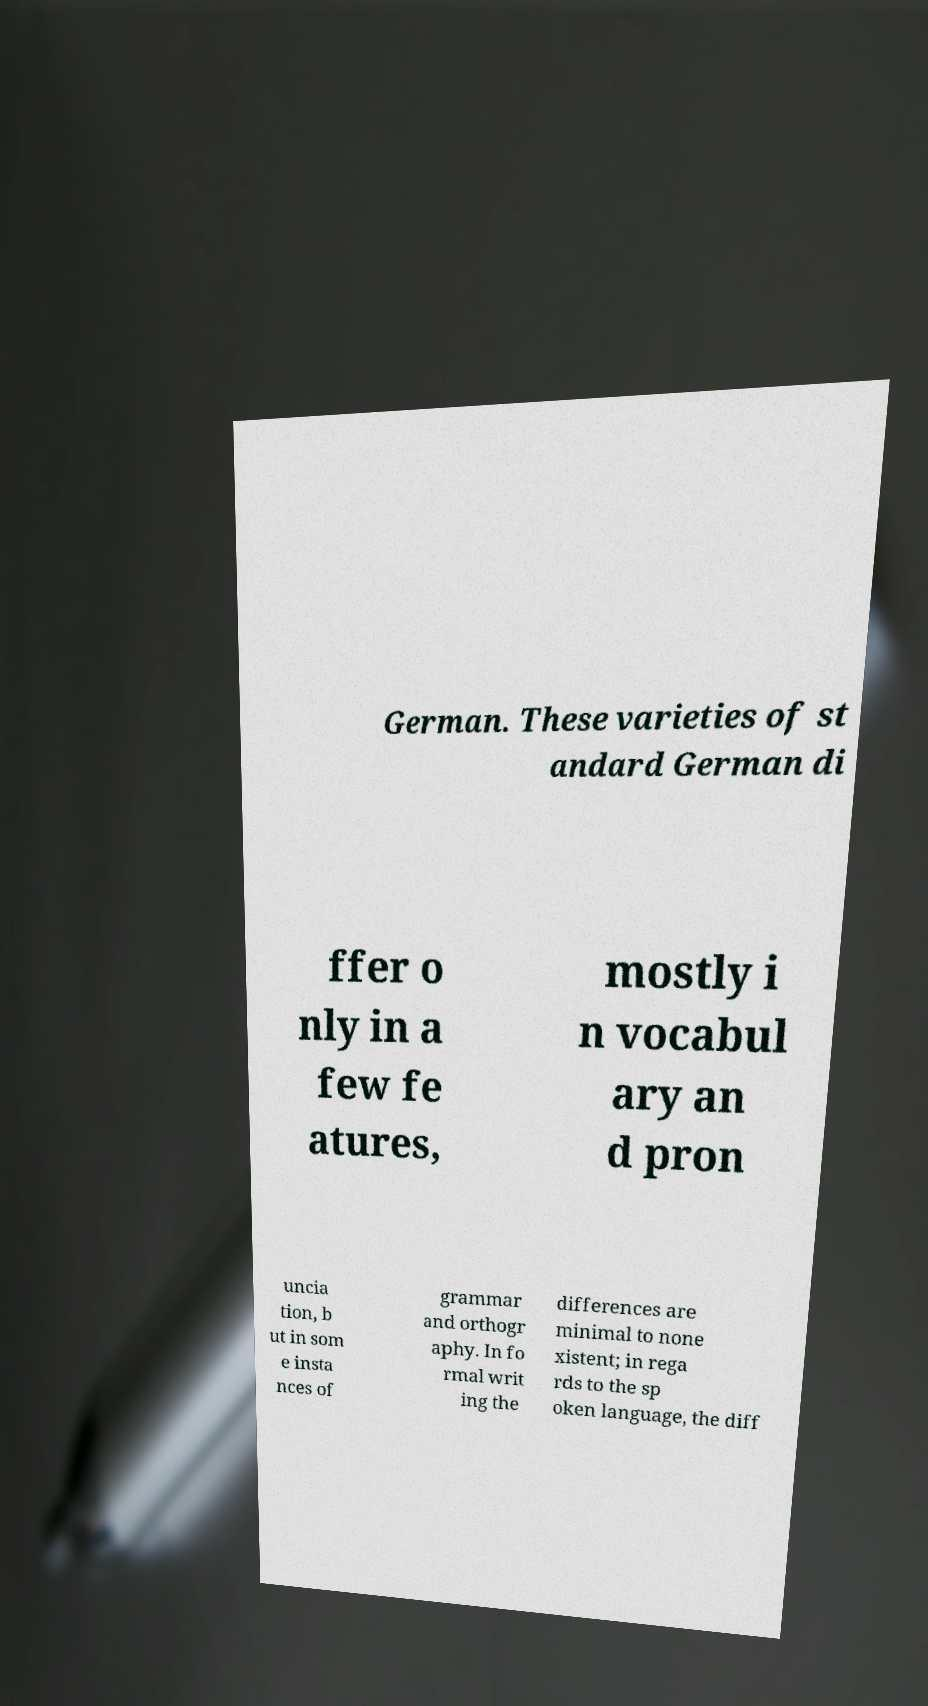Please identify and transcribe the text found in this image. German. These varieties of st andard German di ffer o nly in a few fe atures, mostly i n vocabul ary an d pron uncia tion, b ut in som e insta nces of grammar and orthogr aphy. In fo rmal writ ing the differences are minimal to none xistent; in rega rds to the sp oken language, the diff 